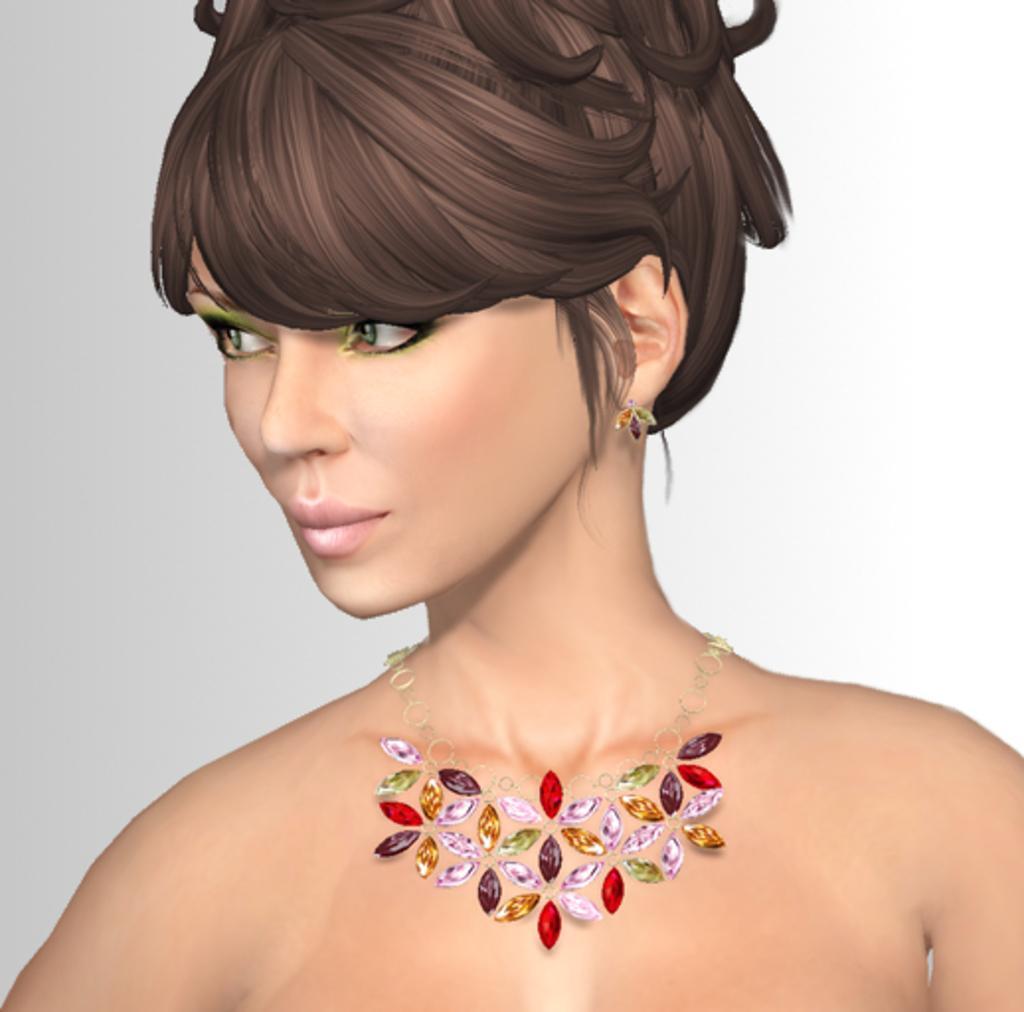Could you give a brief overview of what you see in this image? This image consists of an animated image. In which we can see a woman and a necklace. 